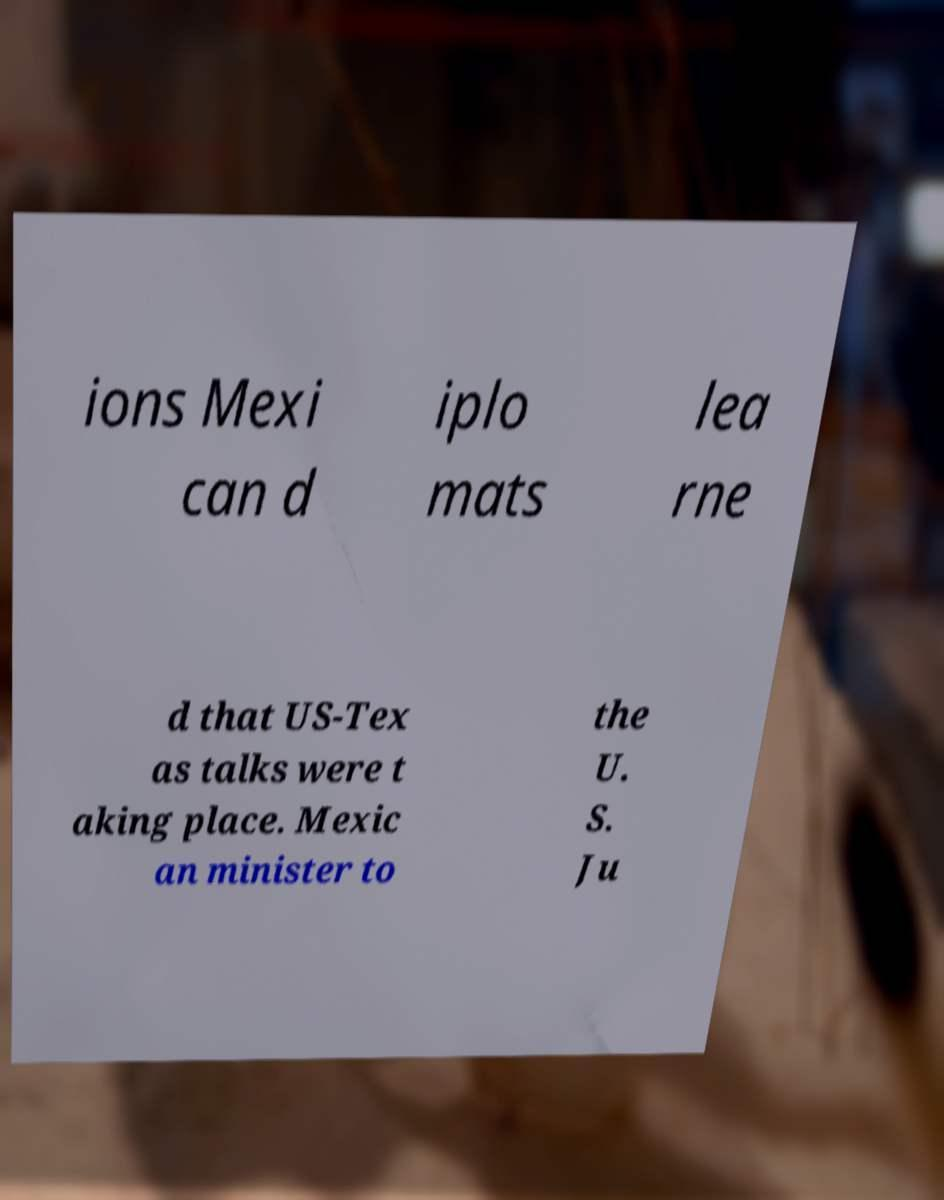Could you extract and type out the text from this image? ions Mexi can d iplo mats lea rne d that US-Tex as talks were t aking place. Mexic an minister to the U. S. Ju 